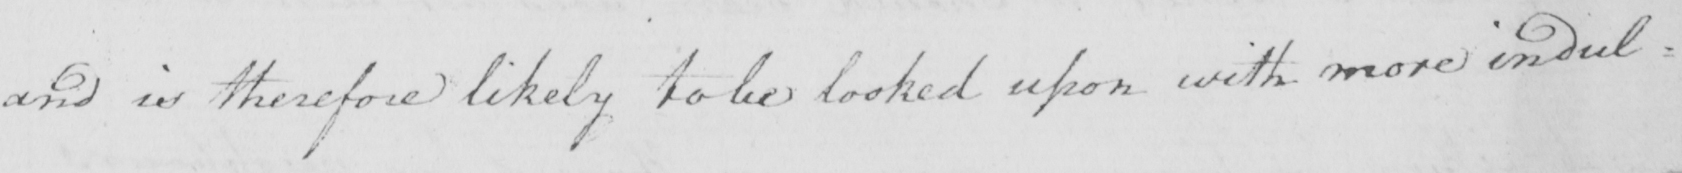Can you tell me what this handwritten text says? and is therefore likely to be looked upon with more indul= 